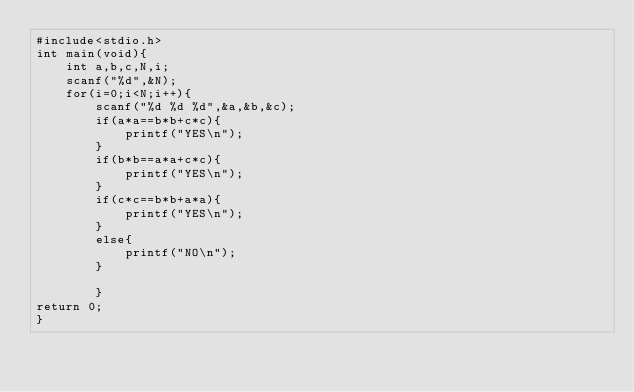Convert code to text. <code><loc_0><loc_0><loc_500><loc_500><_C_>#include<stdio.h>
int main(void){
    int a,b,c,N,i;
    scanf("%d",&N);
    for(i=0;i<N;i++){
        scanf("%d %d %d",&a,&b,&c);
        if(a*a==b*b+c*c){
            printf("YES\n");
        }
        if(b*b==a*a+c*c){
            printf("YES\n");
        }
        if(c*c==b*b+a*a){
            printf("YES\n");
        }
        else{
            printf("NO\n");
        }
        
        }
return 0;
}</code> 